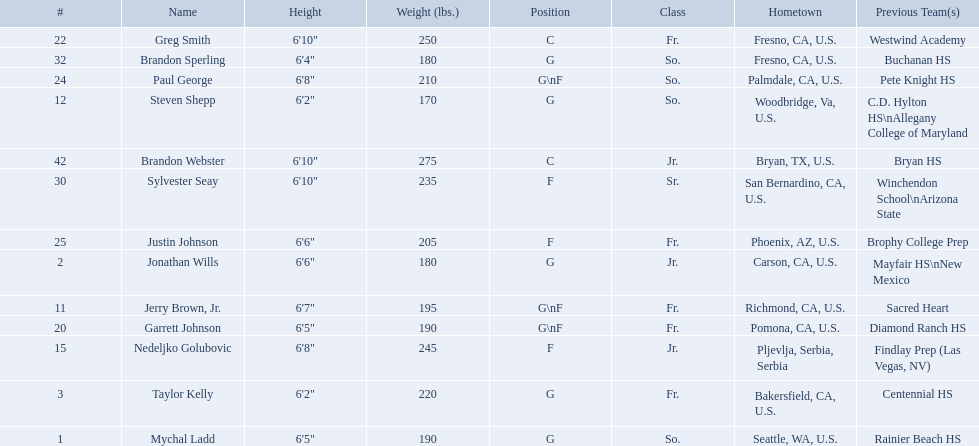Who are all the players? Mychal Ladd, Jonathan Wills, Taylor Kelly, Jerry Brown, Jr., Steven Shepp, Nedeljko Golubovic, Garrett Johnson, Greg Smith, Paul George, Justin Johnson, Sylvester Seay, Brandon Sperling, Brandon Webster. How tall are they? 6'5", 6'6", 6'2", 6'7", 6'2", 6'8", 6'5", 6'10", 6'8", 6'6", 6'10", 6'4", 6'10". What about just paul george and greg smitih? 6'10", 6'8". And which of the two is taller? Greg Smith. 